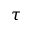<formula> <loc_0><loc_0><loc_500><loc_500>\tau</formula> 